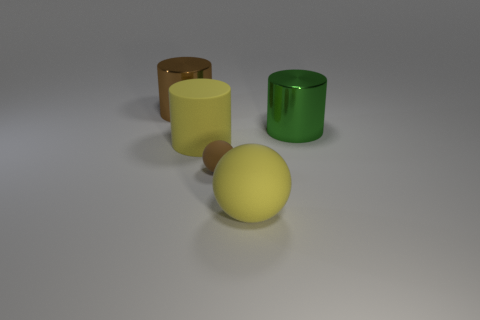What material is the thing that is the same color as the tiny sphere?
Make the answer very short. Metal. What number of other things are the same color as the big matte sphere?
Your answer should be very brief. 1. How many matte things are there?
Your response must be concise. 3. How many objects are both right of the tiny sphere and in front of the yellow cylinder?
Your answer should be very brief. 1. What material is the green cylinder?
Provide a short and direct response. Metal. Are there any large cyan rubber balls?
Your answer should be very brief. No. What color is the tiny matte ball that is behind the yellow rubber sphere?
Provide a short and direct response. Brown. How many brown matte things are behind the brown object that is in front of the large shiny object that is to the left of the green object?
Make the answer very short. 0. What material is the object that is both to the left of the big ball and right of the large rubber cylinder?
Make the answer very short. Rubber. Is the material of the large green cylinder the same as the ball to the right of the small ball?
Your response must be concise. No. 